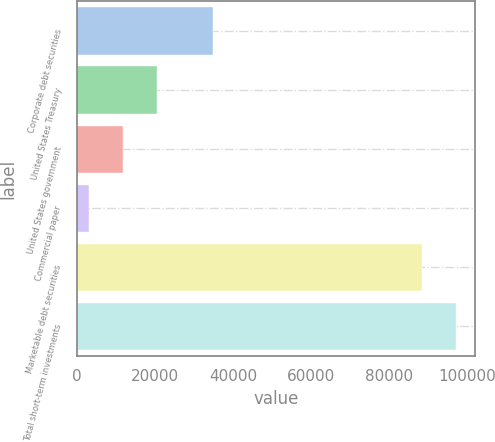<chart> <loc_0><loc_0><loc_500><loc_500><bar_chart><fcel>Corporate debt securities<fcel>United States Treasury<fcel>United States government<fcel>Commercial paper<fcel>Marketable debt securities<fcel>Total short-term investments<nl><fcel>34919<fcel>20628<fcel>11906<fcel>3184<fcel>88587<fcel>97309<nl></chart> 